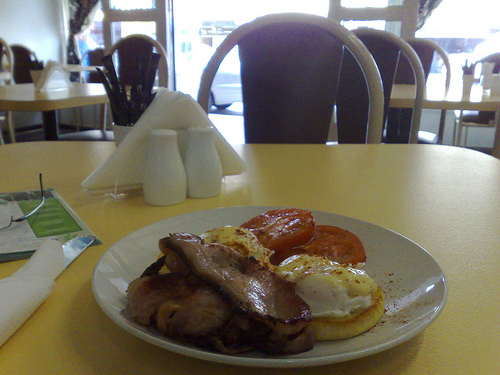<image>
Is the napkin on the plate? No. The napkin is not positioned on the plate. They may be near each other, but the napkin is not supported by or resting on top of the plate. Is the plate on the table? No. The plate is not positioned on the table. They may be near each other, but the plate is not supported by or resting on top of the table. Is the fried egg under the steak? Yes. The fried egg is positioned underneath the steak, with the steak above it in the vertical space. Is the salt shaker above the meat? No. The salt shaker is not positioned above the meat. The vertical arrangement shows a different relationship. 